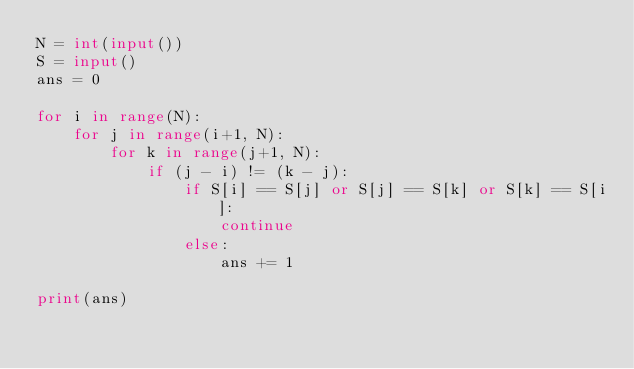Convert code to text. <code><loc_0><loc_0><loc_500><loc_500><_Python_>N = int(input())
S = input()
ans = 0

for i in range(N):
    for j in range(i+1, N):
        for k in range(j+1, N):
            if (j - i) != (k - j):
                if S[i] == S[j] or S[j] == S[k] or S[k] == S[i]:
                    continue
                else:
                    ans += 1

print(ans)</code> 